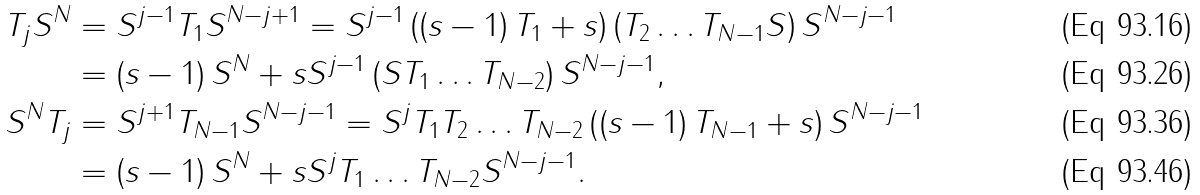Convert formula to latex. <formula><loc_0><loc_0><loc_500><loc_500>T _ { j } S ^ { N } & = S ^ { j - 1 } T _ { 1 } S ^ { N - j + 1 } = S ^ { j - 1 } \left ( \left ( s - 1 \right ) T _ { 1 } + s \right ) \left ( T _ { 2 } \dots T _ { N - 1 } S \right ) S ^ { N - j - 1 } \\ & = \left ( s - 1 \right ) S ^ { N } + s S ^ { j - 1 } \left ( S T _ { 1 } \dots T _ { N - 2 } \right ) S ^ { N - j - 1 } , \\ S ^ { N } T _ { j } & = S ^ { j + 1 } T _ { N - 1 } S ^ { N - j - 1 } = S ^ { j } T _ { 1 } T _ { 2 } \dots T _ { N - 2 } \left ( \left ( s - 1 \right ) T _ { N - 1 } + s \right ) S ^ { N - j - 1 } \\ & = \left ( s - 1 \right ) S ^ { N } + s S ^ { j } T _ { 1 } \dots T _ { N - 2 } S ^ { N - j - 1 } .</formula> 